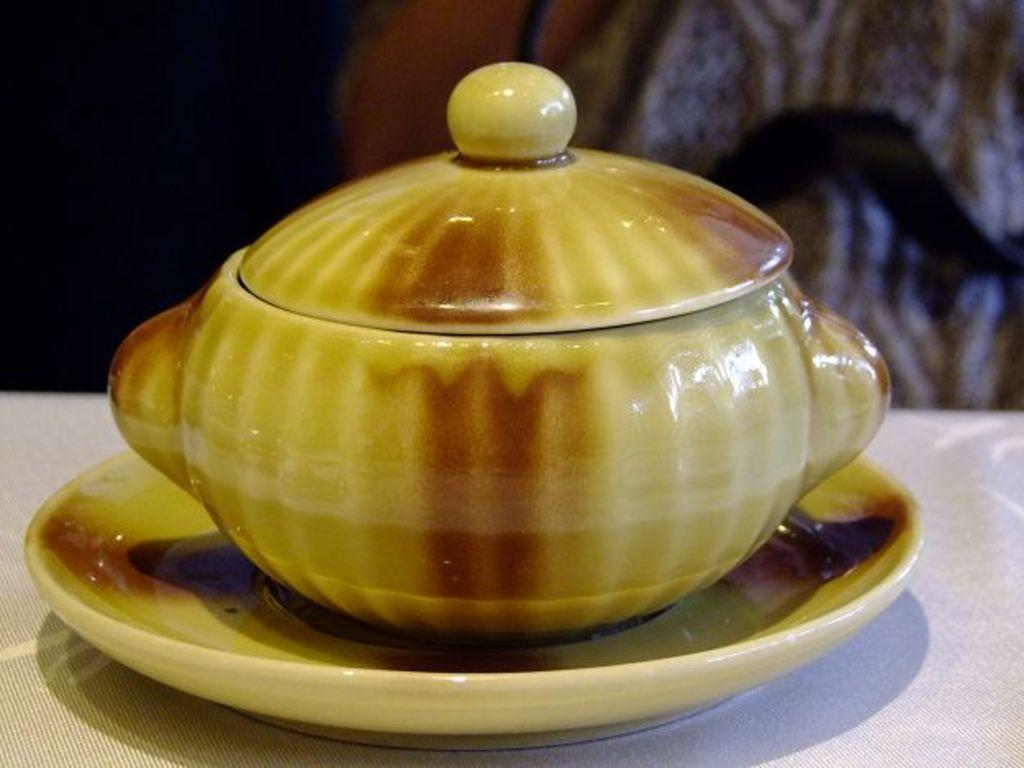What is located in the foreground of the image? There is a cup on a saucer in the foreground of the image. What feature does the cup have? The cup has a lid on it. Where is the cup and saucer placed? They are placed on a table-like structure. Can you describe the background of the image? The background of the image is not clear. What type of activity is taking place in the cemetery in the image? There is no cemetery present in the image, so no activity can be observed in a cemetery. 